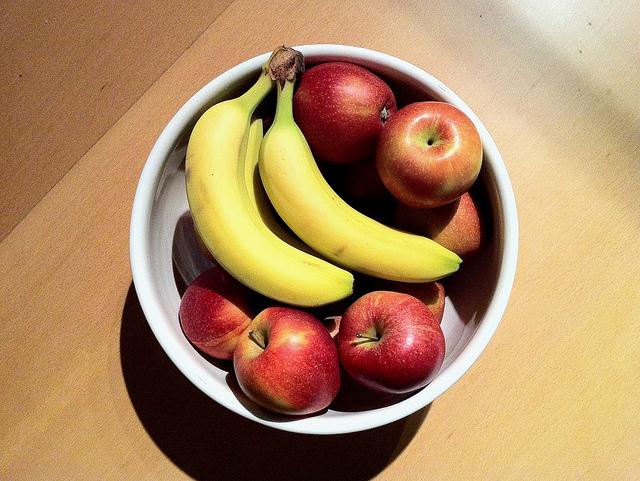How many pie ingredients are shown?
Answer briefly. 2. How many bananas are in this bowl?
Quick response, please. 3. How many different vegetables are in the bowl?
Answer briefly. 2. 